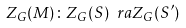<formula> <loc_0><loc_0><loc_500><loc_500>Z _ { G } ( M ) \colon Z _ { G } ( S ) \ r a Z _ { G } ( S ^ { \prime } )</formula> 